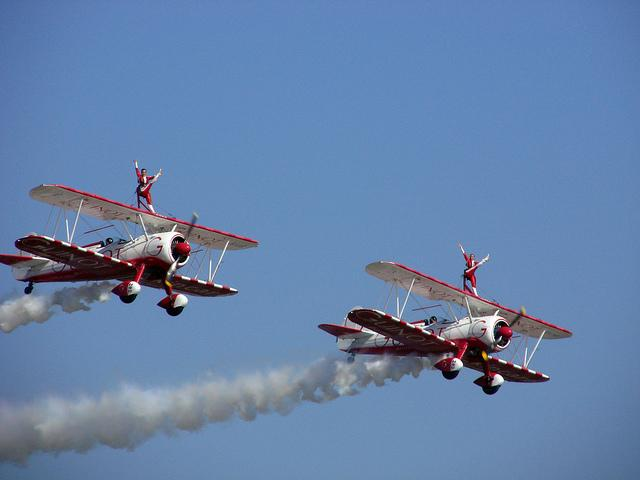What profession do the people on top of the planes belong to?

Choices:
A) acrobats
B) teachers
C) lion tamers
D) pilots acrobats 